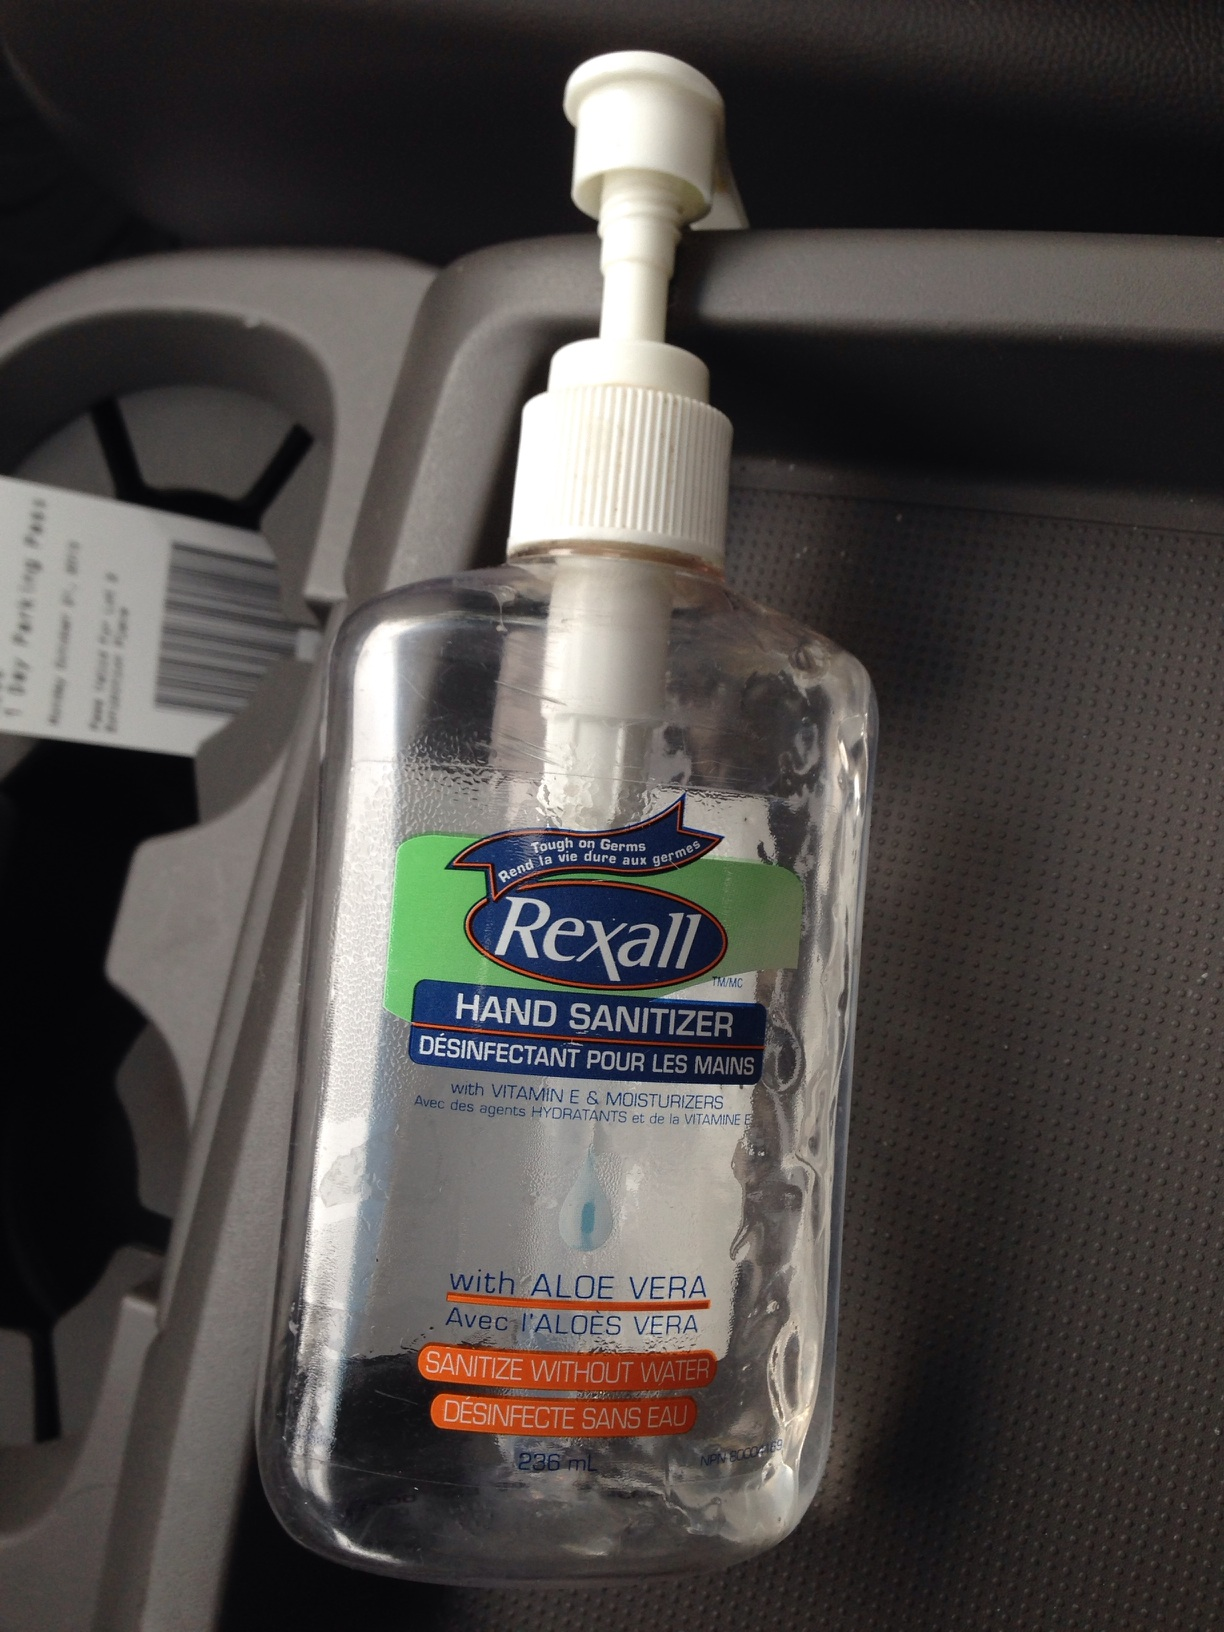Why might aloe vera be added to hand sanitizer? Aloe vera is often added to hand sanitizers for its skin-soothing properties. It helps to moisturize and prevent the dryness that can occur with frequent use of alcohol-based sanitizers, making the product gentler on your skin while still ensuring it's effectively sanitized. 